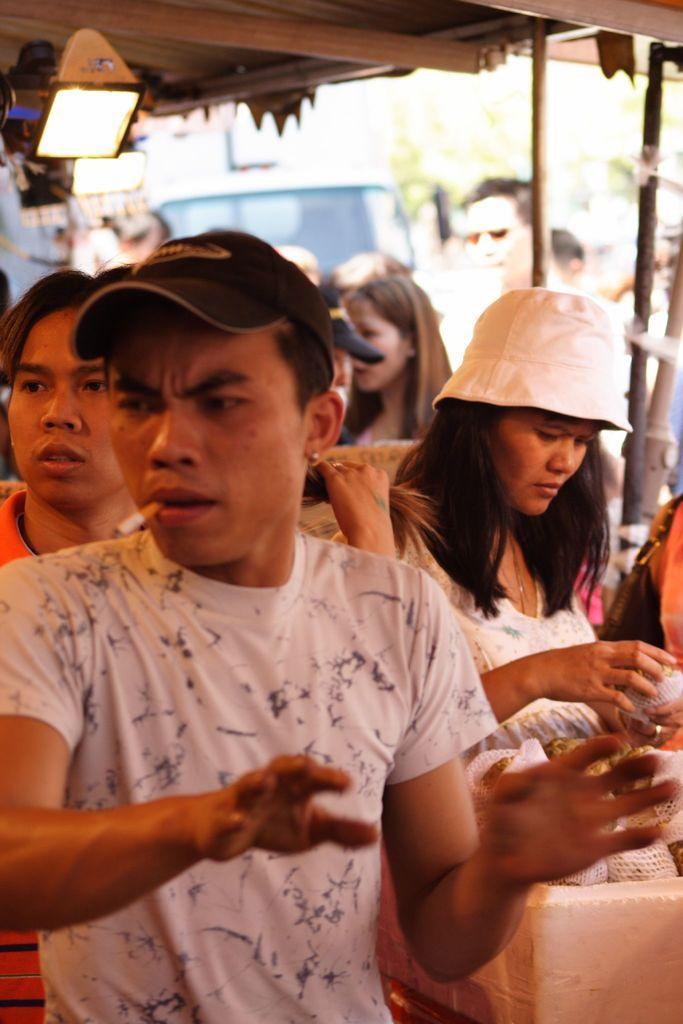Describe this image in one or two sentences. Background portion of the picture is blurry and we can see a vehicle. In this picture we can see poles, people and few objects. We can see a man wearing a cap and we can see a cigarette in his mouth. We can see a woman wearing a cap and she is holding an object. 